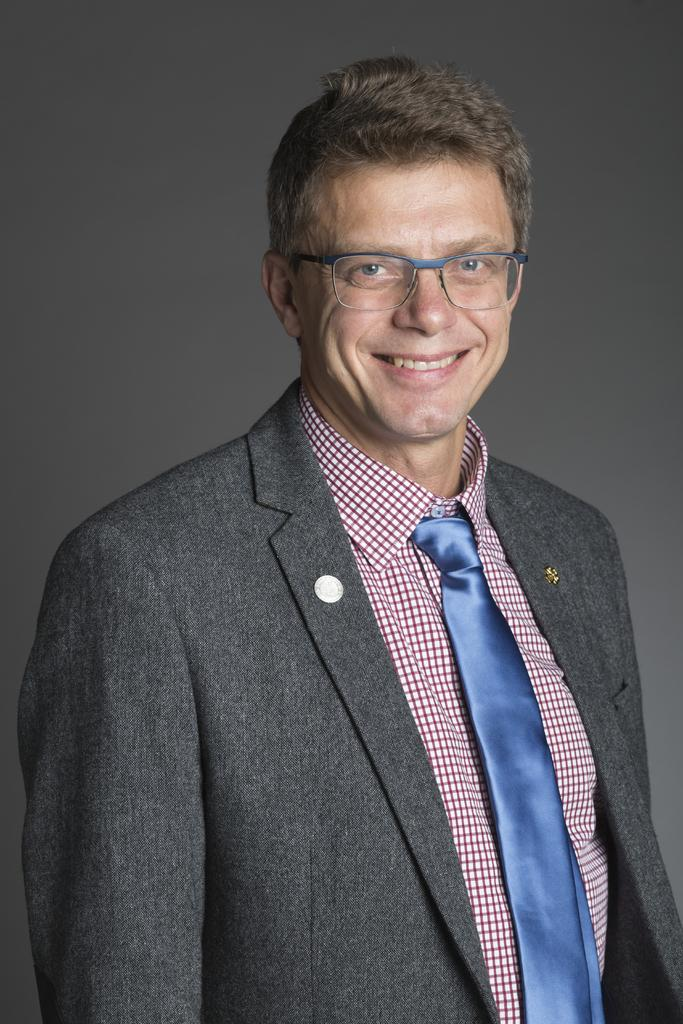What is the main subject of the image? The main subject of the image is a man. What is the man wearing in the image? The man is wearing a suit, a shirt, and a tie in the image. What is the man's facial expression in the image? The man is smiling in the image. What is the man doing in the image? The man is giving a pose for the picture in the image. What type of breakfast is the man eating in the image? There is no breakfast present in the image; it only features a man posing for a picture. Can you tell me how many girls are visible in the image? There are no girls present in the image; it only features a man posing for a picture. 